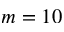<formula> <loc_0><loc_0><loc_500><loc_500>m = 1 0</formula> 